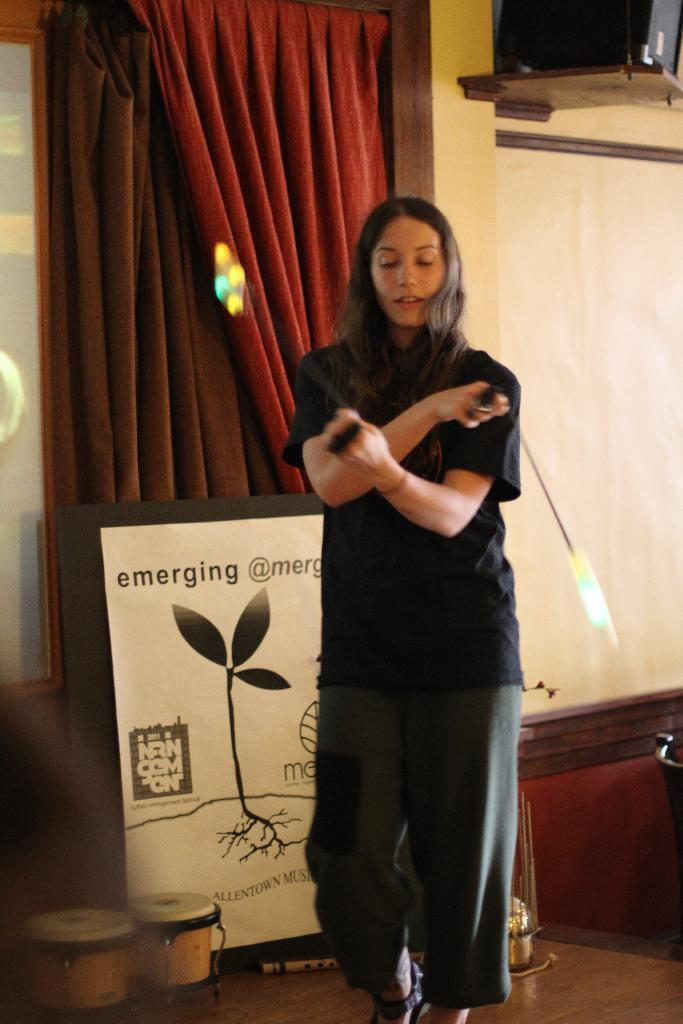What is the main subject of the image? There is a person in the image. Can you describe the person's clothing? The person is wearing a black t-shirt and trousers. What can be seen in the background of the image? There are drums, a banner, and curtains in the background of the image. Where is the speaker located in the image? The speaker is on the right top of the image. How many pails are visible in the image? There are no pails present in the image. What type of beds can be seen in the image? There are no beds present in the image. 